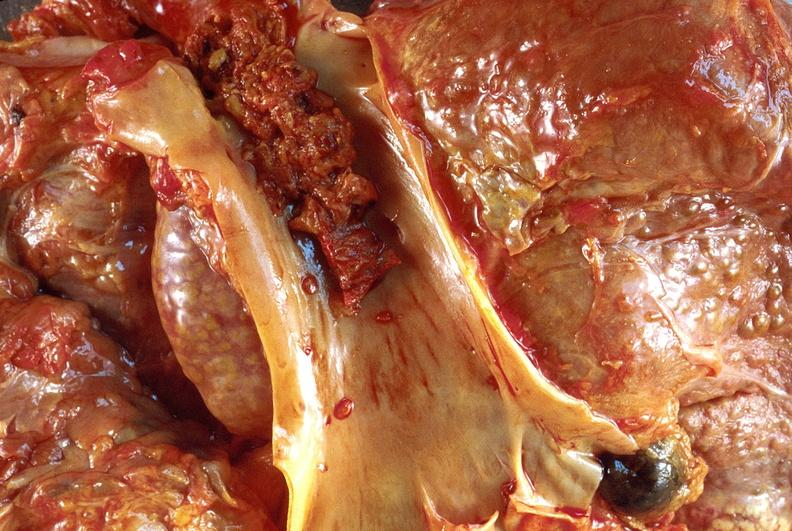does this image show hepatocellular carcinoma, hepatitis c positive?
Answer the question using a single word or phrase. Yes 